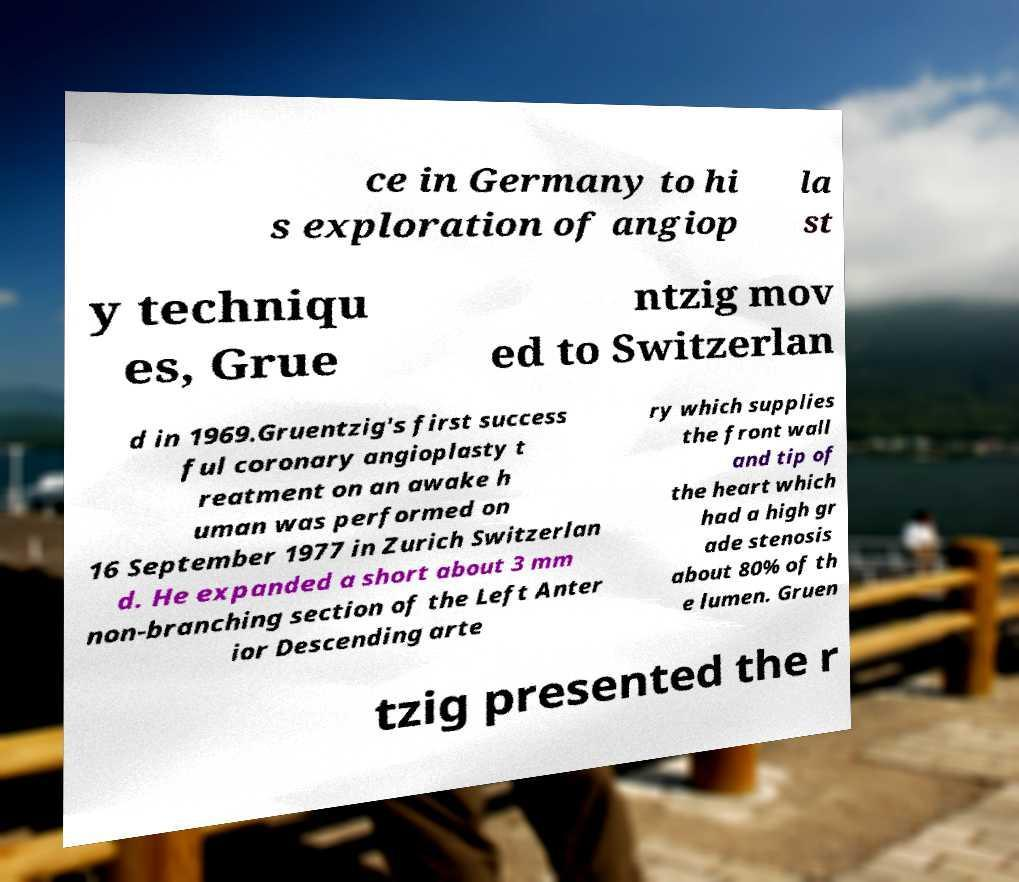What messages or text are displayed in this image? I need them in a readable, typed format. ce in Germany to hi s exploration of angiop la st y techniqu es, Grue ntzig mov ed to Switzerlan d in 1969.Gruentzig's first success ful coronary angioplasty t reatment on an awake h uman was performed on 16 September 1977 in Zurich Switzerlan d. He expanded a short about 3 mm non-branching section of the Left Anter ior Descending arte ry which supplies the front wall and tip of the heart which had a high gr ade stenosis about 80% of th e lumen. Gruen tzig presented the r 